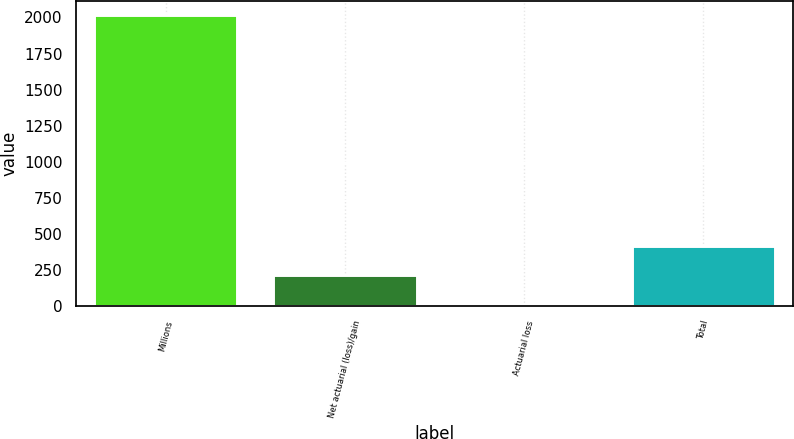Convert chart. <chart><loc_0><loc_0><loc_500><loc_500><bar_chart><fcel>Millions<fcel>Net actuarial (loss)/gain<fcel>Actuarial loss<fcel>Total<nl><fcel>2015<fcel>213.2<fcel>13<fcel>413.4<nl></chart> 